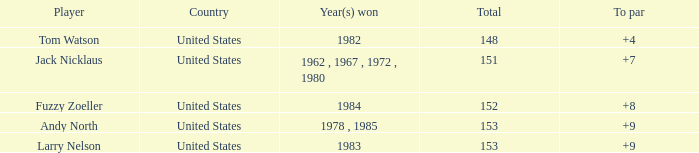What is the to par of the player who won in 1983? 9.0. 